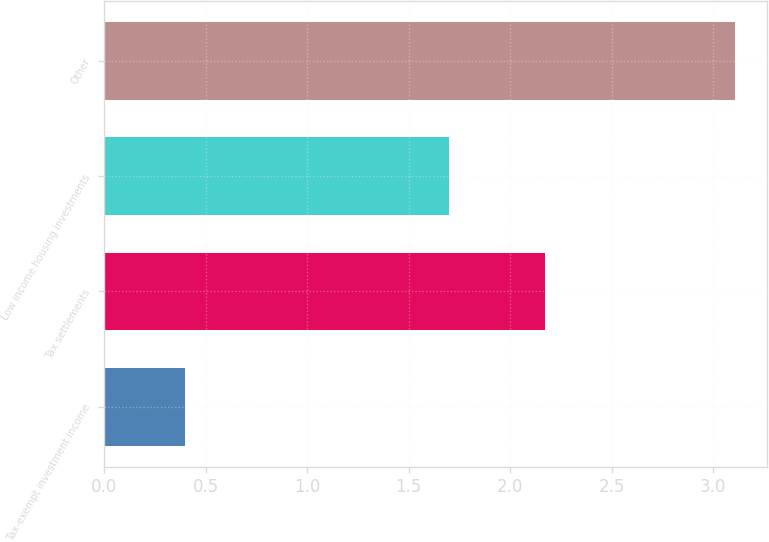<chart> <loc_0><loc_0><loc_500><loc_500><bar_chart><fcel>Tax-exempt investment income<fcel>Tax settlements<fcel>Low income housing investments<fcel>Other<nl><fcel>0.4<fcel>2.17<fcel>1.7<fcel>3.11<nl></chart> 